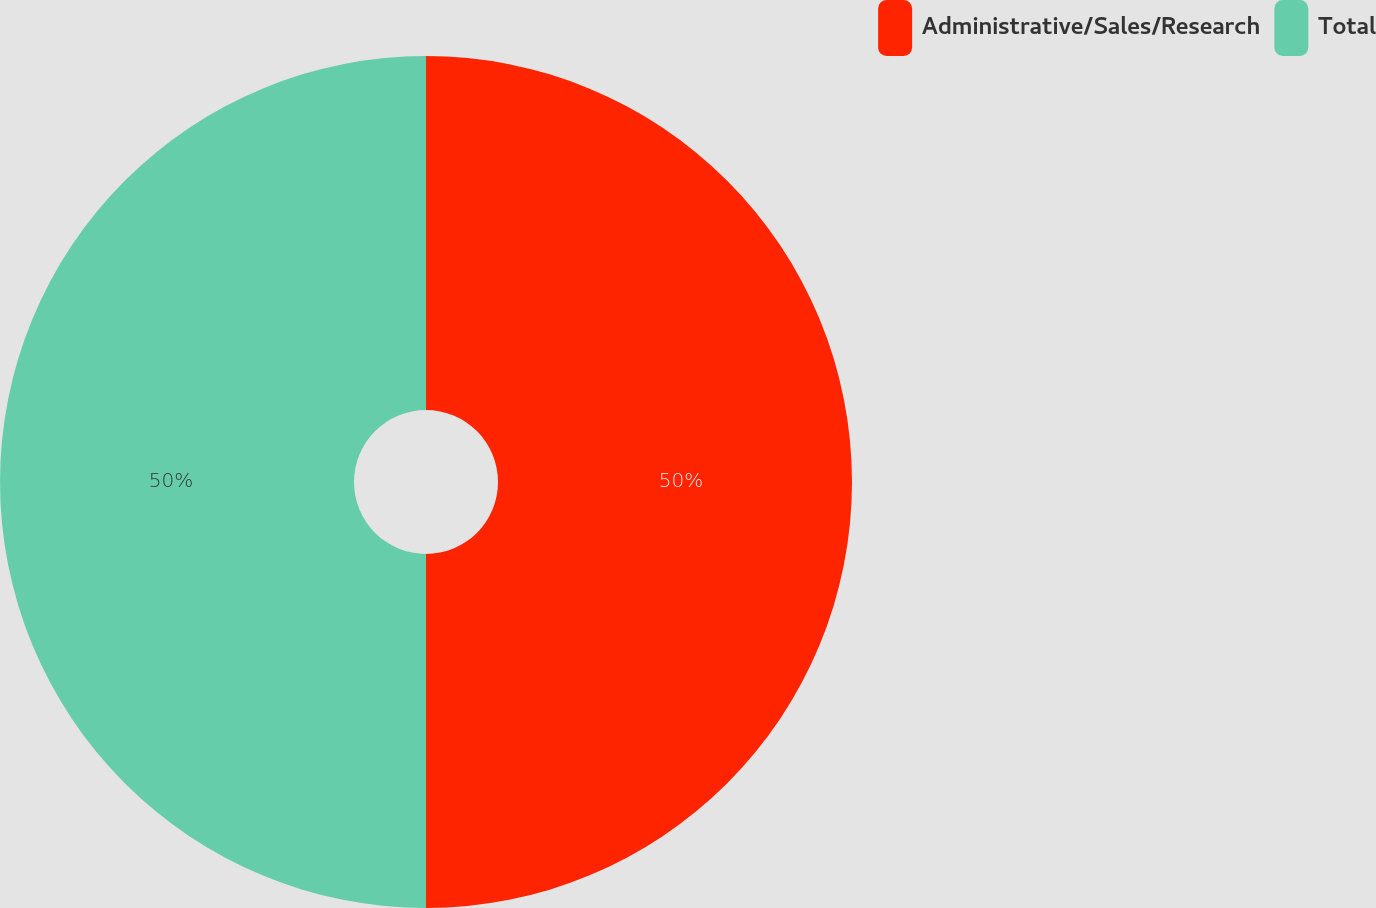<chart> <loc_0><loc_0><loc_500><loc_500><pie_chart><fcel>Administrative/Sales/Research<fcel>Total<nl><fcel>50.0%<fcel>50.0%<nl></chart> 